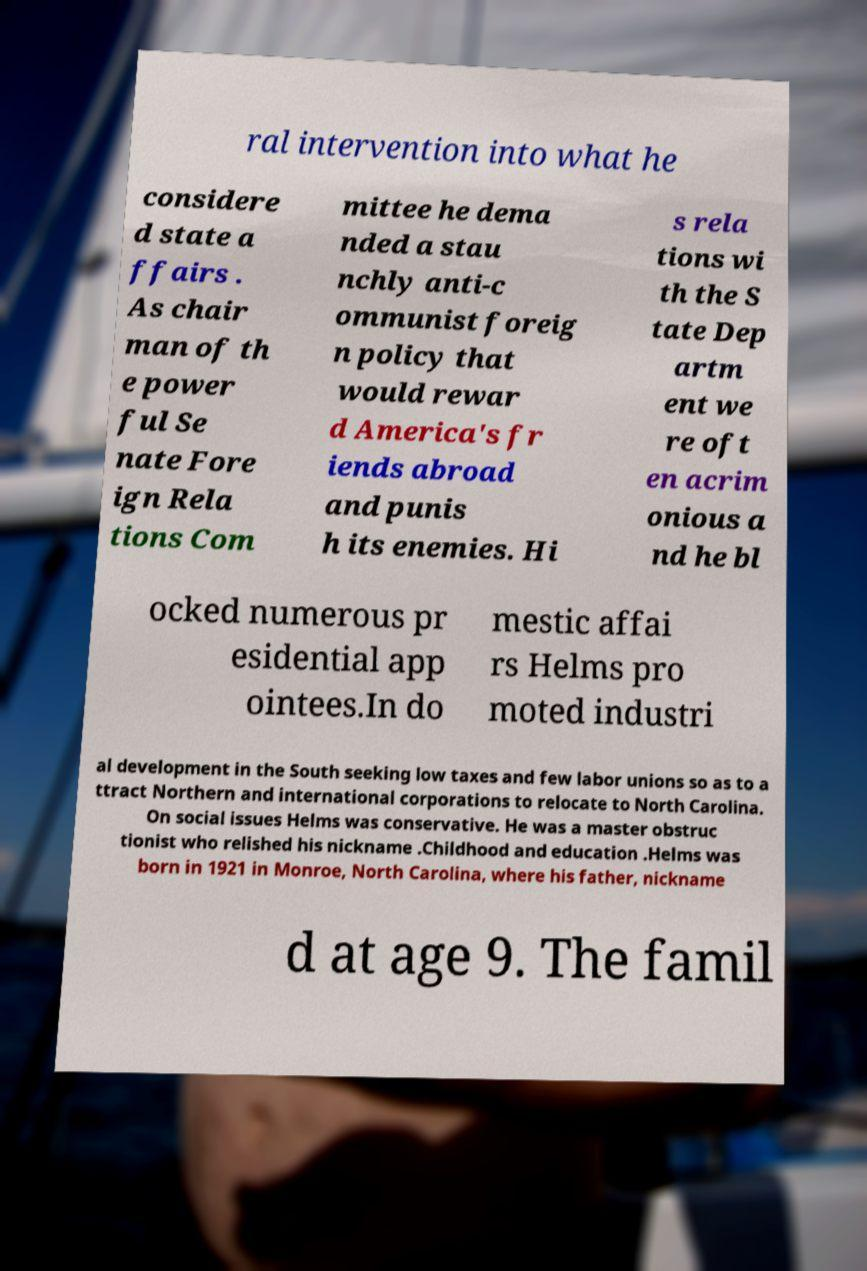Can you accurately transcribe the text from the provided image for me? ral intervention into what he considere d state a ffairs . As chair man of th e power ful Se nate Fore ign Rela tions Com mittee he dema nded a stau nchly anti-c ommunist foreig n policy that would rewar d America's fr iends abroad and punis h its enemies. Hi s rela tions wi th the S tate Dep artm ent we re oft en acrim onious a nd he bl ocked numerous pr esidential app ointees.In do mestic affai rs Helms pro moted industri al development in the South seeking low taxes and few labor unions so as to a ttract Northern and international corporations to relocate to North Carolina. On social issues Helms was conservative. He was a master obstruc tionist who relished his nickname .Childhood and education .Helms was born in 1921 in Monroe, North Carolina, where his father, nickname d at age 9. The famil 